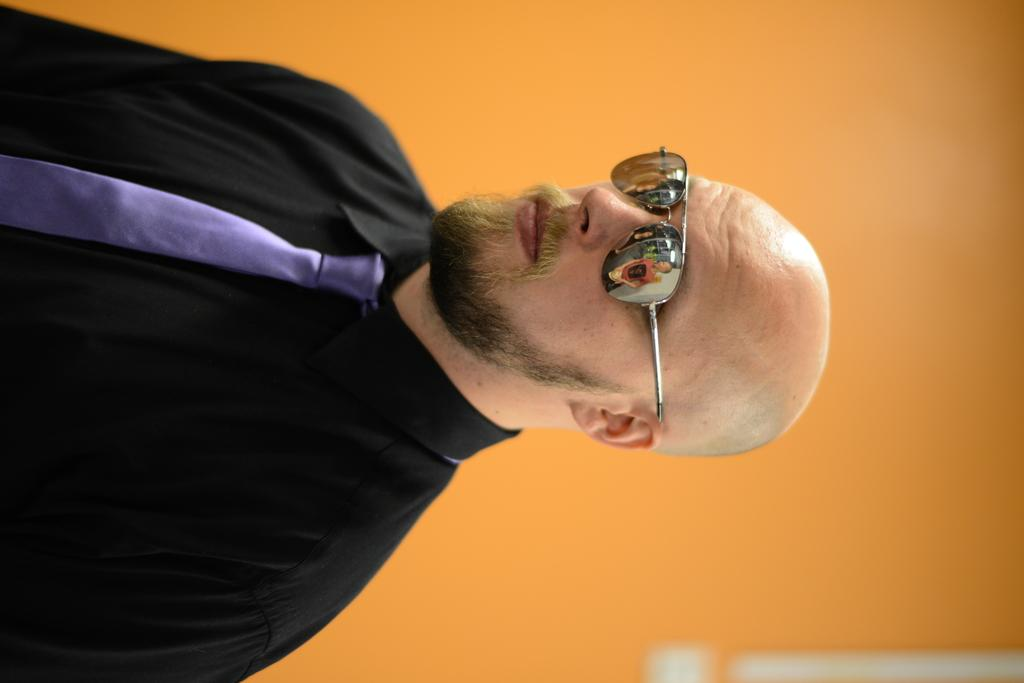Who or what is the main subject of the image? There is a person in the image. What is the person wearing on their upper body? The person is wearing a black shirt. What accessory is the person wearing around their neck? The person is wearing a purple tie. What is the person wearing on their face to aid in vision? The person is wearing glasses. What color is the background of the image? The background of the image is in orange color. How many fingers does the person have on their left hand in the image? The image does not provide enough detail to determine the number of fingers the person has on their left hand. 